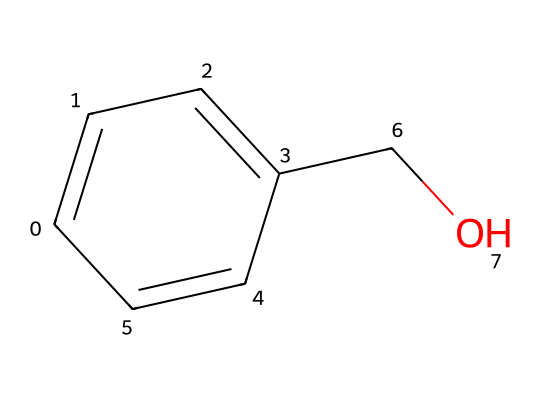What is the total number of carbon atoms in this chemical? By examining the SMILES representation, we can identify the number of carbon atoms indicated by the letter "C." In this structure, there are six instances of "C" in total, which represent the carbon atoms present in the benzyl alcohol structure.
Answer: 6 How many hydroxyl (–OH) groups are present in benzyl alcohol? The SMILES representation includes a "CO" segment, which corresponds to a hydroxyl (–OH) group attached to the benzene ring. This indicates that there is one hydroxyl group in the structure of benzyl alcohol.
Answer: 1 What type of chemical bond connects the carbon atoms in benzyl alcohol? The carbon atoms in benzyl alcohol are primarily connected by single bonds (indicated by the absence of numbers in the SMILES), with a double bond between two carbon atoms in the aromatic ring. This suggests that most connections are single bonds.
Answer: single What is the primary functional group present in benzyl alcohol? The hydroxyl (–OH) group is the defining characteristic of alcohols; it is present in the structure indicated by "CO" in the SMILES. Therefore, the primary functional group in benzyl alcohol is the hydroxyl group.
Answer: hydroxyl Does benzyl alcohol exhibit aromatic properties? The presence of a six-membered carbon ring (the benzene portion) within the SMILES structure indicates that it has aromatic properties, due to the delocalized pi electrons in the ring configuration.
Answer: yes Which type of aroma does benzyl alcohol contribute? Benzyl alcohol typically has a sweet, floral aroma reminiscent of jasmine or similar flowers. This quality can be inferred from its chemical structure and known applications in flavors and fragrances.
Answer: sweet floral 